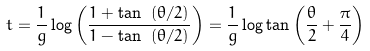<formula> <loc_0><loc_0><loc_500><loc_500>t = \frac { 1 } { g } \log \left ( \frac { 1 + \tan \ ( \theta / 2 ) } { 1 - \tan \ ( \theta / 2 ) } \right ) = \frac { 1 } { g } \log \tan \left ( \frac { \theta } { 2 } + \frac { \pi } { 4 } \right )</formula> 